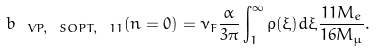<formula> <loc_0><loc_0><loc_500><loc_500>b _ { \ V P , \ S O P T , \ 1 1 } ( n = 0 ) = \nu _ { F } \frac { \alpha } { 3 \pi } \int _ { 1 } ^ { \infty } \rho ( \xi ) d \xi \frac { 1 1 M _ { e } } { 1 6 M _ { \mu } } .</formula> 